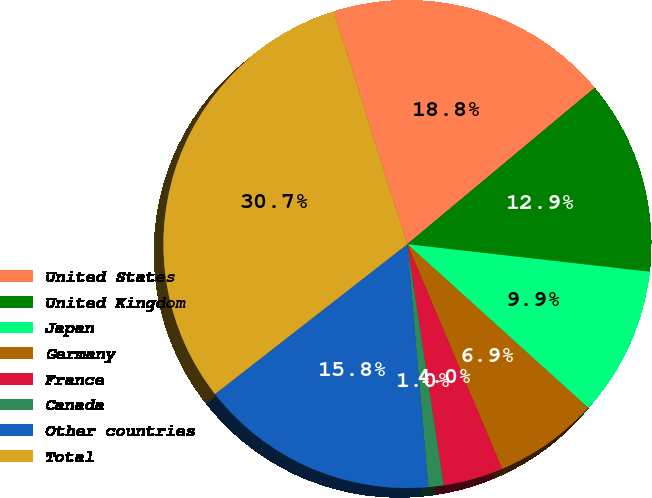Convert chart. <chart><loc_0><loc_0><loc_500><loc_500><pie_chart><fcel>United States<fcel>United Kingdom<fcel>Japan<fcel>Germany<fcel>France<fcel>Canada<fcel>Other countries<fcel>Total<nl><fcel>18.8%<fcel>12.87%<fcel>9.9%<fcel>6.94%<fcel>3.97%<fcel>1.01%<fcel>15.84%<fcel>30.67%<nl></chart> 